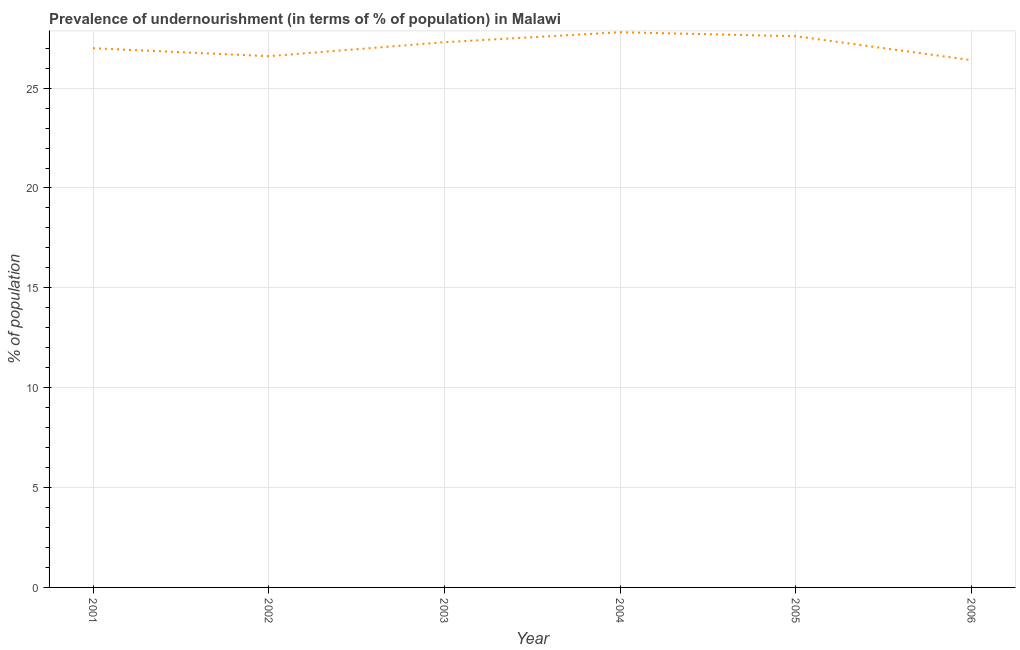What is the percentage of undernourished population in 2003?
Provide a short and direct response. 27.3. Across all years, what is the maximum percentage of undernourished population?
Provide a succinct answer. 27.8. Across all years, what is the minimum percentage of undernourished population?
Keep it short and to the point. 26.4. In which year was the percentage of undernourished population maximum?
Provide a succinct answer. 2004. What is the sum of the percentage of undernourished population?
Offer a terse response. 162.7. What is the difference between the percentage of undernourished population in 2002 and 2004?
Provide a short and direct response. -1.2. What is the average percentage of undernourished population per year?
Give a very brief answer. 27.12. What is the median percentage of undernourished population?
Give a very brief answer. 27.15. What is the ratio of the percentage of undernourished population in 2003 to that in 2004?
Provide a succinct answer. 0.98. Is the percentage of undernourished population in 2001 less than that in 2002?
Ensure brevity in your answer.  No. Is the difference between the percentage of undernourished population in 2003 and 2004 greater than the difference between any two years?
Your answer should be compact. No. What is the difference between the highest and the second highest percentage of undernourished population?
Ensure brevity in your answer.  0.2. What is the difference between the highest and the lowest percentage of undernourished population?
Ensure brevity in your answer.  1.4. In how many years, is the percentage of undernourished population greater than the average percentage of undernourished population taken over all years?
Your answer should be compact. 3. Does the percentage of undernourished population monotonically increase over the years?
Offer a very short reply. No. How many lines are there?
Keep it short and to the point. 1. How many years are there in the graph?
Your answer should be compact. 6. Does the graph contain any zero values?
Your response must be concise. No. Does the graph contain grids?
Offer a terse response. Yes. What is the title of the graph?
Keep it short and to the point. Prevalence of undernourishment (in terms of % of population) in Malawi. What is the label or title of the Y-axis?
Keep it short and to the point. % of population. What is the % of population of 2002?
Ensure brevity in your answer.  26.6. What is the % of population in 2003?
Ensure brevity in your answer.  27.3. What is the % of population of 2004?
Provide a short and direct response. 27.8. What is the % of population of 2005?
Your answer should be very brief. 27.6. What is the % of population of 2006?
Offer a very short reply. 26.4. What is the difference between the % of population in 2001 and 2004?
Your response must be concise. -0.8. What is the difference between the % of population in 2001 and 2005?
Offer a very short reply. -0.6. What is the difference between the % of population in 2002 and 2003?
Keep it short and to the point. -0.7. What is the difference between the % of population in 2002 and 2004?
Offer a very short reply. -1.2. What is the difference between the % of population in 2003 and 2006?
Offer a very short reply. 0.9. What is the difference between the % of population in 2004 and 2005?
Keep it short and to the point. 0.2. What is the difference between the % of population in 2004 and 2006?
Give a very brief answer. 1.4. What is the ratio of the % of population in 2001 to that in 2003?
Your answer should be compact. 0.99. What is the ratio of the % of population in 2001 to that in 2005?
Your answer should be compact. 0.98. What is the ratio of the % of population in 2001 to that in 2006?
Your answer should be very brief. 1.02. What is the ratio of the % of population in 2002 to that in 2003?
Ensure brevity in your answer.  0.97. What is the ratio of the % of population in 2002 to that in 2004?
Your response must be concise. 0.96. What is the ratio of the % of population in 2003 to that in 2004?
Offer a terse response. 0.98. What is the ratio of the % of population in 2003 to that in 2006?
Make the answer very short. 1.03. What is the ratio of the % of population in 2004 to that in 2005?
Your answer should be compact. 1.01. What is the ratio of the % of population in 2004 to that in 2006?
Your response must be concise. 1.05. What is the ratio of the % of population in 2005 to that in 2006?
Your answer should be very brief. 1.04. 